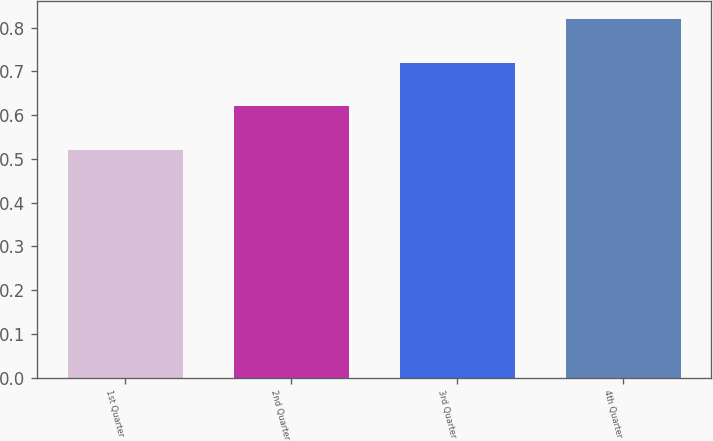Convert chart to OTSL. <chart><loc_0><loc_0><loc_500><loc_500><bar_chart><fcel>1st Quarter<fcel>2nd Quarter<fcel>3rd Quarter<fcel>4th Quarter<nl><fcel>0.52<fcel>0.62<fcel>0.72<fcel>0.82<nl></chart> 